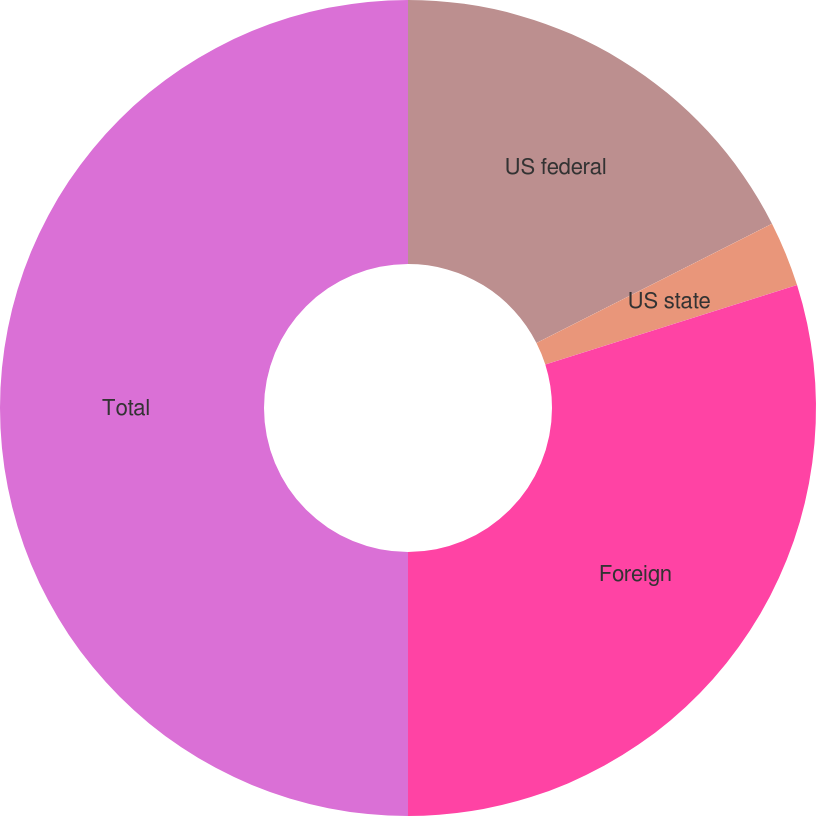Convert chart. <chart><loc_0><loc_0><loc_500><loc_500><pie_chart><fcel>US federal<fcel>US state<fcel>Foreign<fcel>Total<nl><fcel>17.54%<fcel>2.59%<fcel>29.87%<fcel>50.0%<nl></chart> 